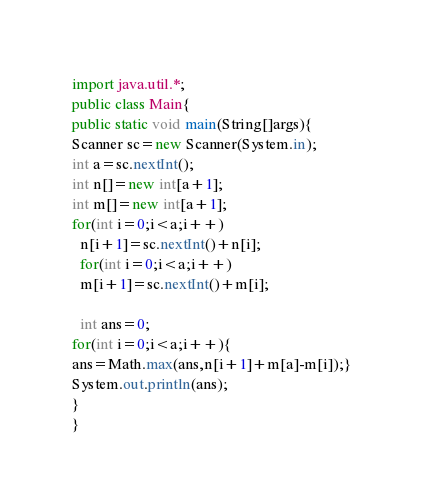Convert code to text. <code><loc_0><loc_0><loc_500><loc_500><_Java_>import java.util.*;
public class Main{
public static void main(String[]args){
Scanner sc=new Scanner(System.in);
int a=sc.nextInt();
int n[]=new int[a+1];
int m[]=new int[a+1];
for(int i=0;i<a;i++)
  n[i+1]=sc.nextInt()+n[i];
  for(int i=0;i<a;i++)
  m[i+1]=sc.nextInt()+m[i];

  int ans=0;
for(int i=0;i<a;i++){
ans=Math.max(ans,n[i+1]+m[a]-m[i]);}
System.out.println(ans);
}
}</code> 